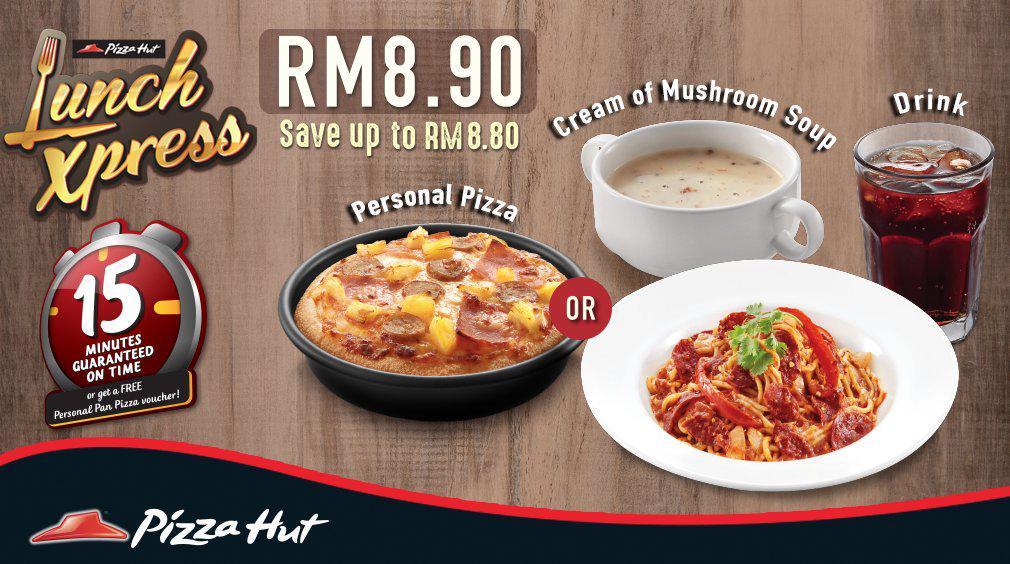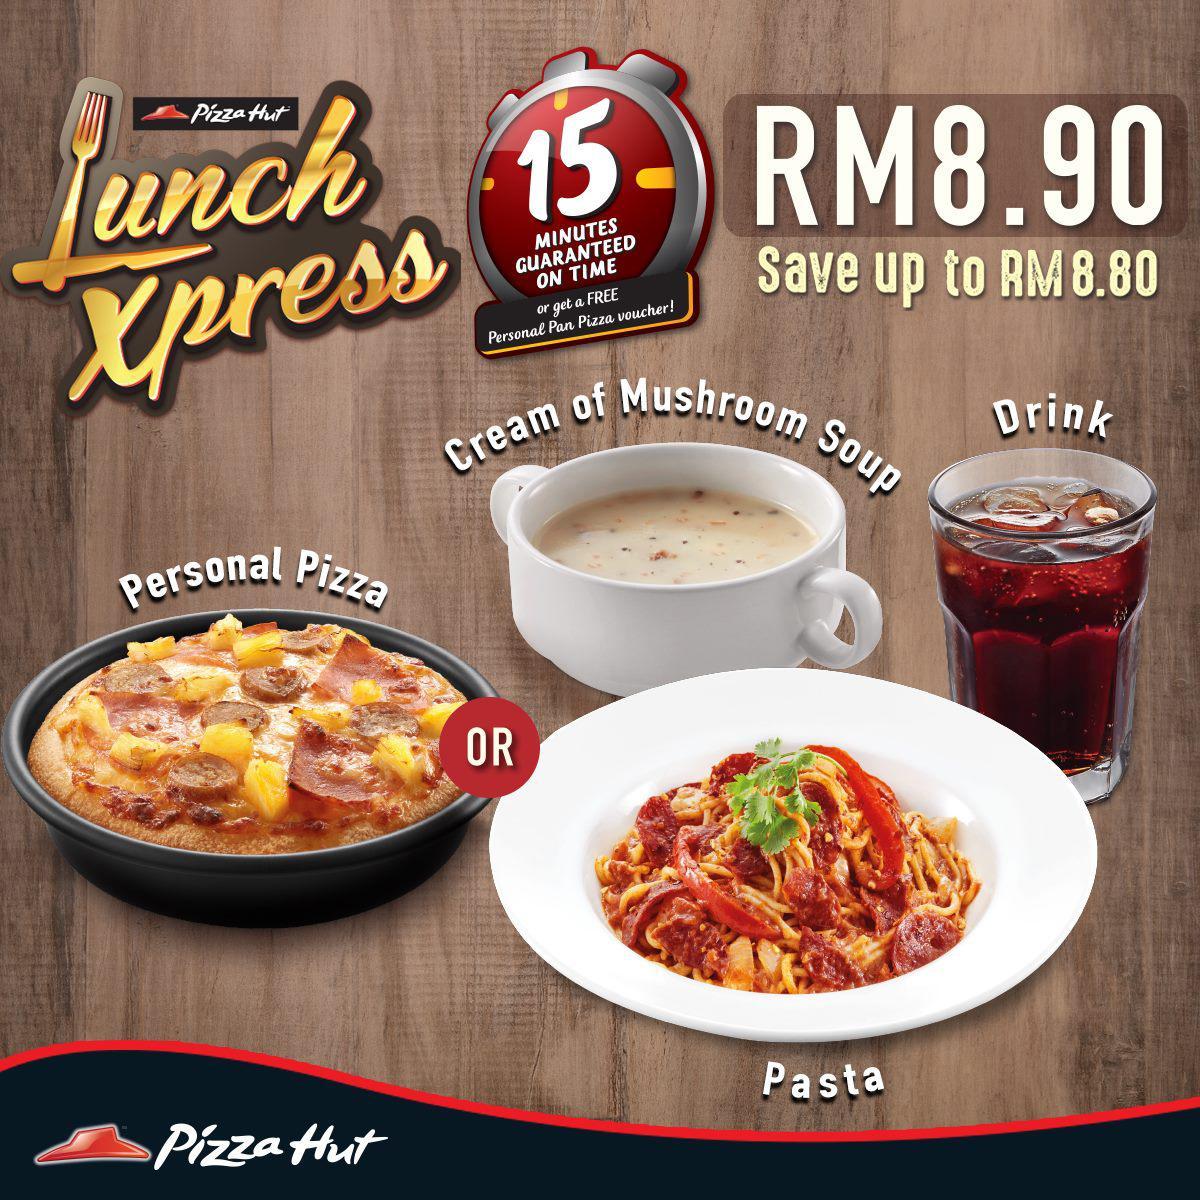The first image is the image on the left, the second image is the image on the right. For the images shown, is this caption "The right image includes a cartoon clock and contains the same number of food items as the left image." true? Answer yes or no. Yes. The first image is the image on the left, the second image is the image on the right. Evaluate the accuracy of this statement regarding the images: "In at least on image ad, there is both a pizza an at least three mozzarella sticks.". Is it true? Answer yes or no. No. 